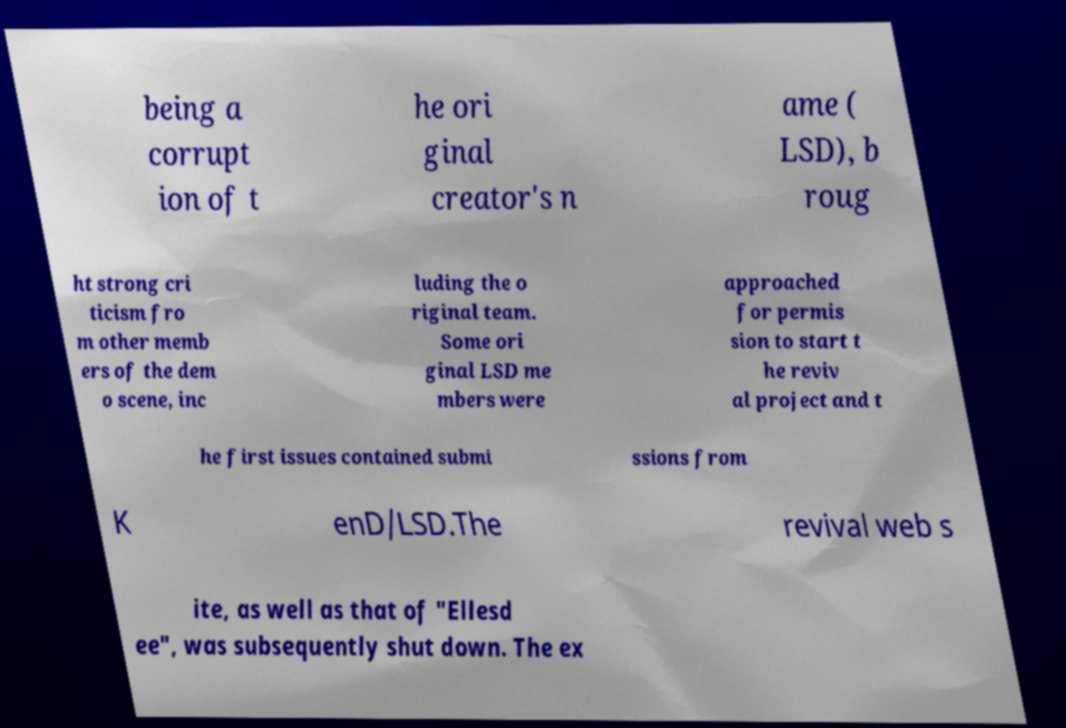I need the written content from this picture converted into text. Can you do that? being a corrupt ion of t he ori ginal creator's n ame ( LSD), b roug ht strong cri ticism fro m other memb ers of the dem o scene, inc luding the o riginal team. Some ori ginal LSD me mbers were approached for permis sion to start t he reviv al project and t he first issues contained submi ssions from K enD/LSD.The revival web s ite, as well as that of "Ellesd ee", was subsequently shut down. The ex 